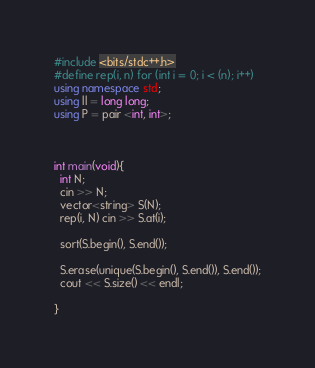<code> <loc_0><loc_0><loc_500><loc_500><_C++_>#include <bits/stdc++.h>
#define rep(i, n) for (int i = 0; i < (n); i++)
using namespace std;
using ll = long long;
using P = pair <int, int>;



int main(void){
  int N;
  cin >> N;
  vector<string> S(N);
  rep(i, N) cin >> S.at(i);

  sort(S.begin(), S.end());

  S.erase(unique(S.begin(), S.end()), S.end());
  cout << S.size() << endl;

}
</code> 